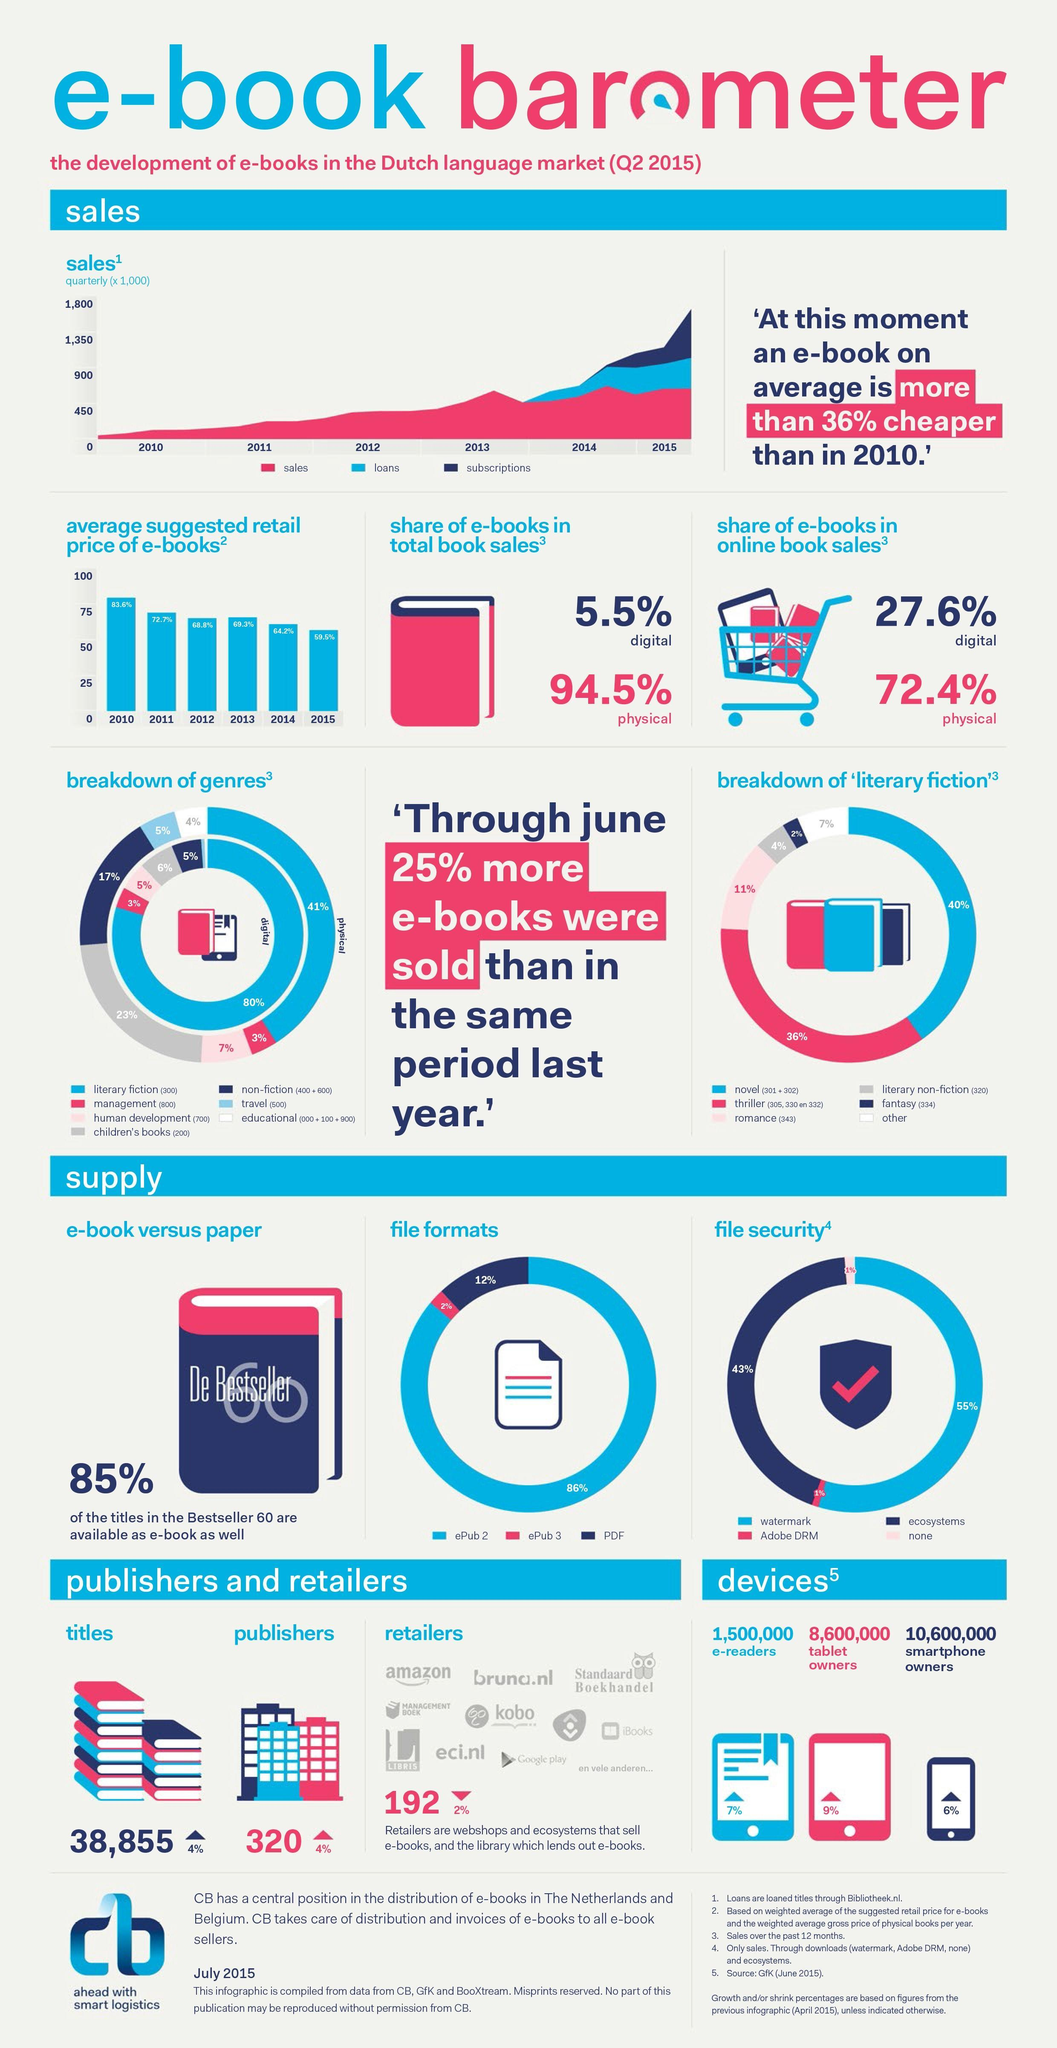What is the number of smartphone owners?
Answer the question with a short phrase. 10,600,000 What is the number of tablet owners? 8,600,000 